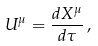Convert formula to latex. <formula><loc_0><loc_0><loc_500><loc_500>U ^ { \mu } & = \frac { d X ^ { \mu } } { d \tau } \, ,</formula> 